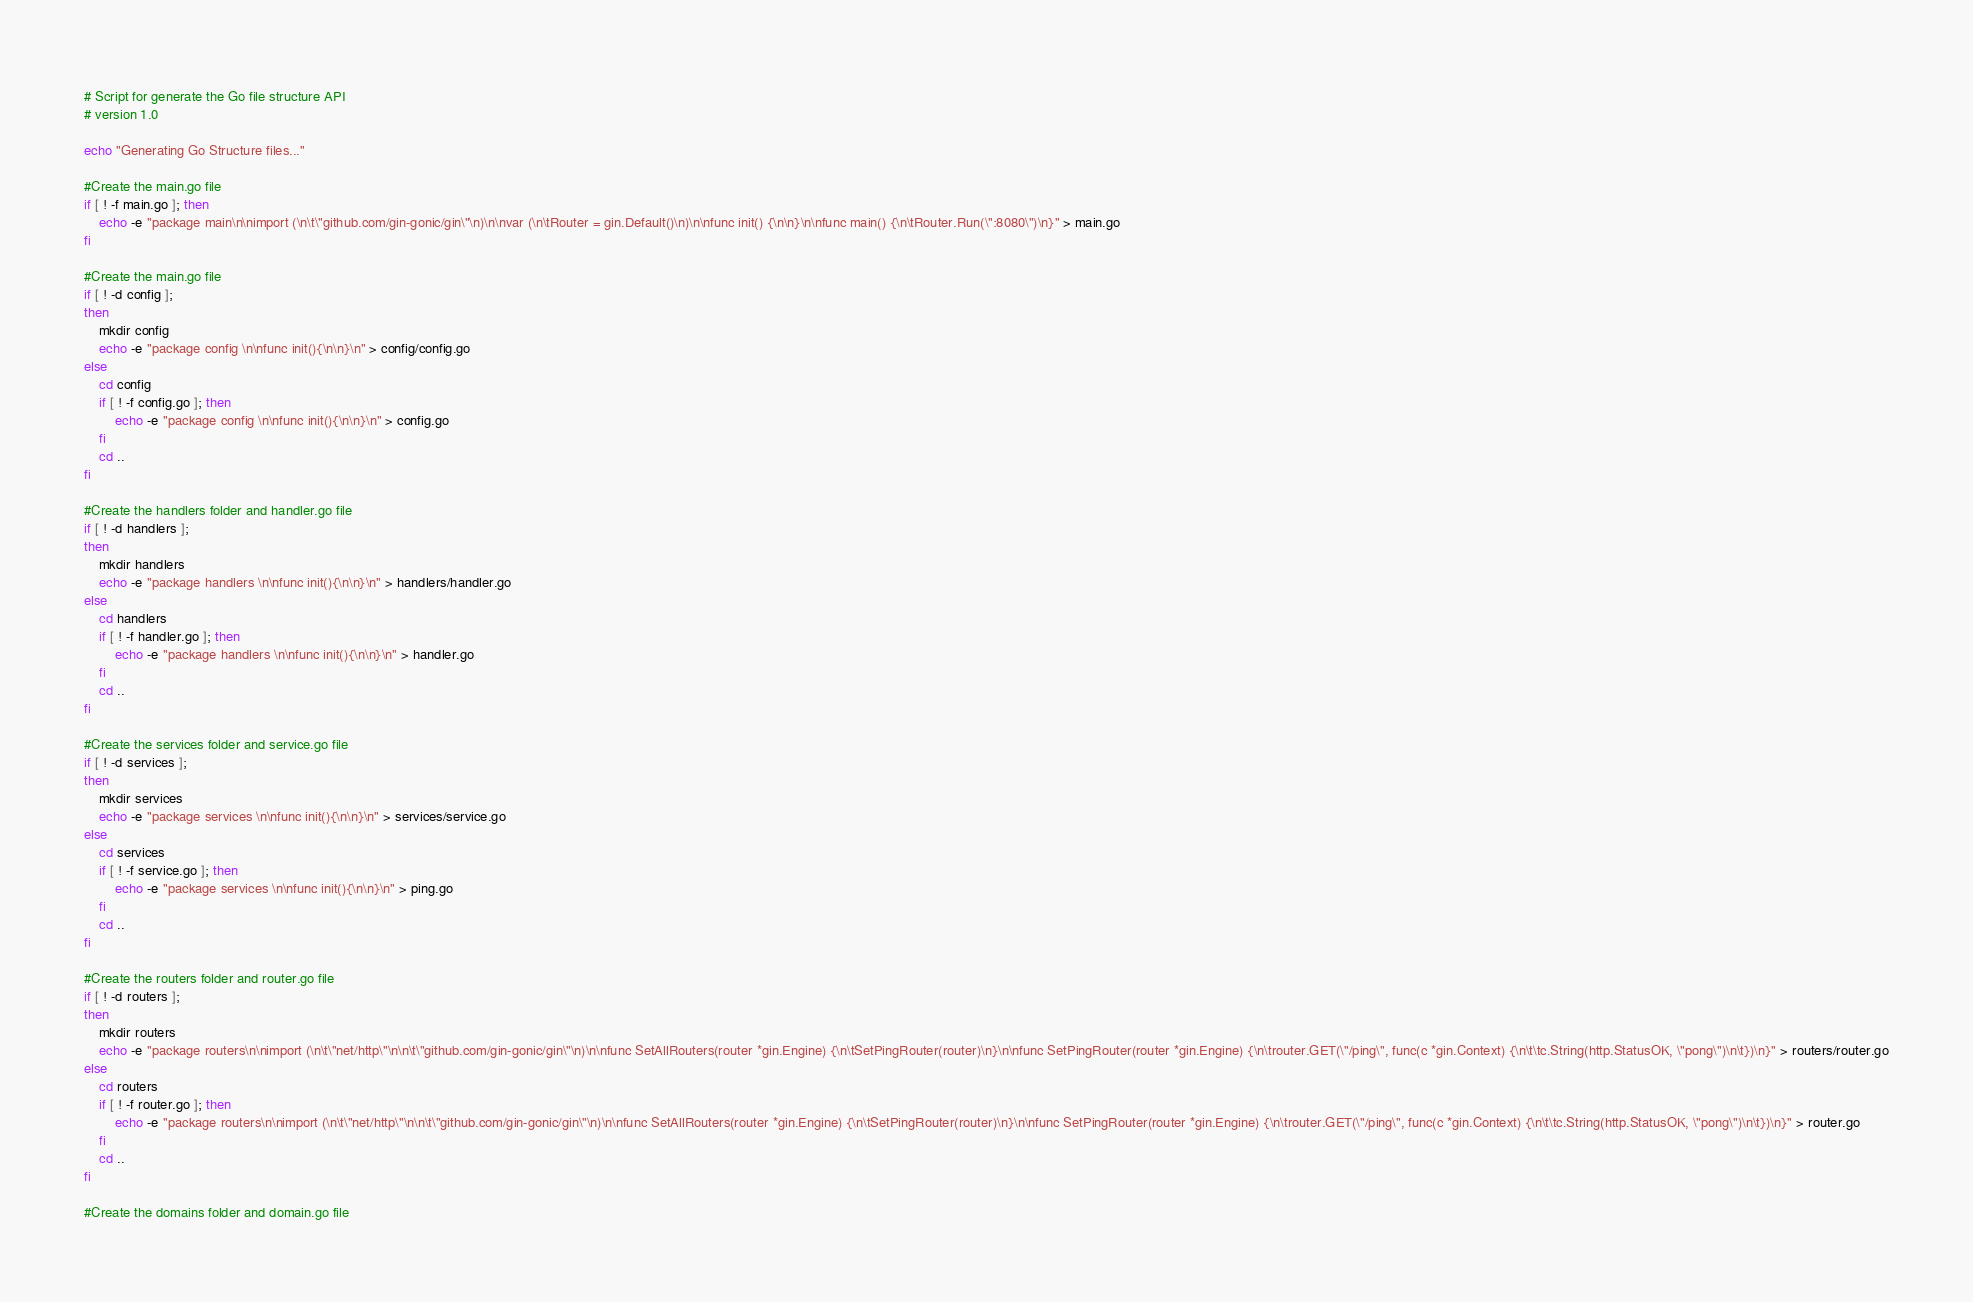<code> <loc_0><loc_0><loc_500><loc_500><_Bash_># Script for generate the Go file structure API
# version 1.0

echo "Generating Go Structure files..."

#Create the main.go file
if [ ! -f main.go ]; then
    echo -e "package main\n\nimport (\n\t\"github.com/gin-gonic/gin\"\n)\n\nvar (\n\tRouter = gin.Default()\n)\n\nfunc init() {\n\n}\n\nfunc main() {\n\tRouter.Run(\":8080\")\n}" > main.go
fi

#Create the main.go file
if [ ! -d config ]; 
then	
	mkdir config
    echo -e "package config \n\nfunc init(){\n\n}\n" > config/config.go
else
	cd config
    if [ ! -f config.go ]; then
    	echo -e "package config \n\nfunc init(){\n\n}\n" > config.go
    fi
    cd ..
fi

#Create the handlers folder and handler.go file
if [ ! -d handlers ]; 
then	
	mkdir handlers
    echo -e "package handlers \n\nfunc init(){\n\n}\n" > handlers/handler.go
else
	cd handlers
    if [ ! -f handler.go ]; then
    	echo -e "package handlers \n\nfunc init(){\n\n}\n" > handler.go
    fi
    cd ..
fi

#Create the services folder and service.go file
if [ ! -d services ]; 
then	
	mkdir services
    echo -e "package services \n\nfunc init(){\n\n}\n" > services/service.go
else
	cd services
    if [ ! -f service.go ]; then
    	echo -e "package services \n\nfunc init(){\n\n}\n" > ping.go
    fi
    cd ..
fi

#Create the routers folder and router.go file
if [ ! -d routers ]; 
then	
	mkdir routers
    echo -e "package routers\n\nimport (\n\t\"net/http\"\n\n\t\"github.com/gin-gonic/gin\"\n)\n\nfunc SetAllRouters(router *gin.Engine) {\n\tSetPingRouter(router)\n}\n\nfunc SetPingRouter(router *gin.Engine) {\n\trouter.GET(\"/ping\", func(c *gin.Context) {\n\t\tc.String(http.StatusOK, \"pong\")\n\t})\n}" > routers/router.go
else
	cd routers
    if [ ! -f router.go ]; then
    	echo -e "package routers\n\nimport (\n\t\"net/http\"\n\n\t\"github.com/gin-gonic/gin\"\n)\n\nfunc SetAllRouters(router *gin.Engine) {\n\tSetPingRouter(router)\n}\n\nfunc SetPingRouter(router *gin.Engine) {\n\trouter.GET(\"/ping\", func(c *gin.Context) {\n\t\tc.String(http.StatusOK, \"pong\")\n\t})\n}" > router.go
    fi
    cd ..
fi

#Create the domains folder and domain.go file</code> 